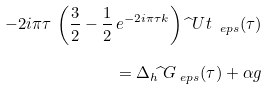<formula> <loc_0><loc_0><loc_500><loc_500>- 2 i \pi \tau \, \left ( \frac { 3 } { 2 } - \frac { 1 } { 2 } \, e ^ { - 2 i \pi \tau k } \right ) \widehat { \ } U t _ { \ e p s } ( \tau ) \\ = \Delta _ { h } \widehat { \ } G _ { \ e p s } ( \tau ) + \alpha g</formula> 